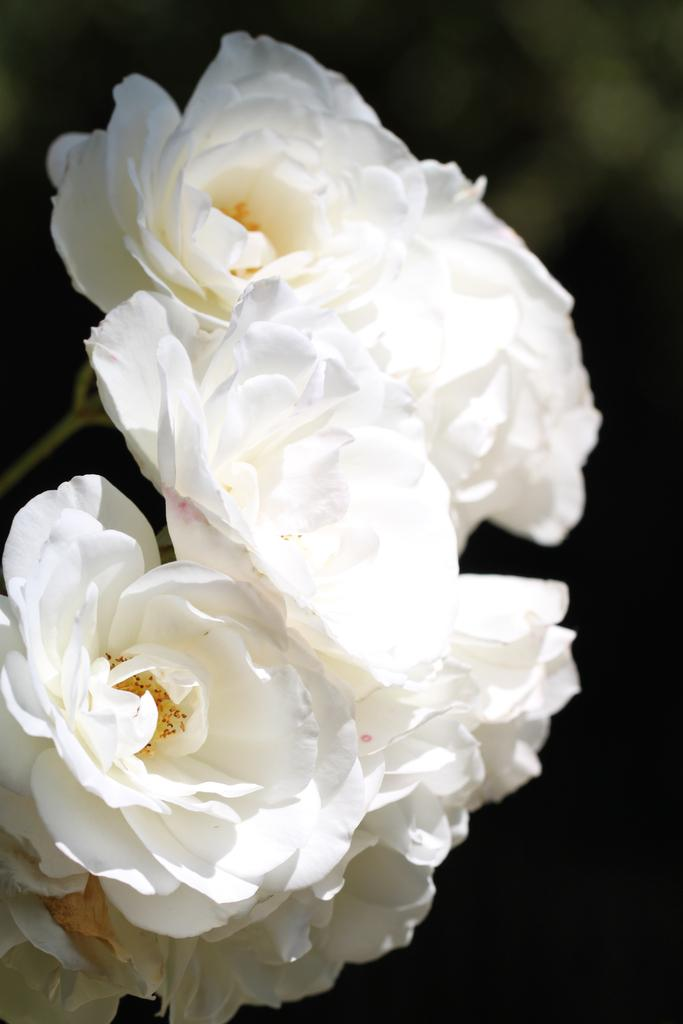What type of flora is present in the image? There are flowers in the image. What color are the flowers? The flowers are white in color. Can you describe the background of the image? The background of the image is blurred. What language does the queen speak in the image? There is no queen present in the image, so it is not possible to determine what language she might speak. 